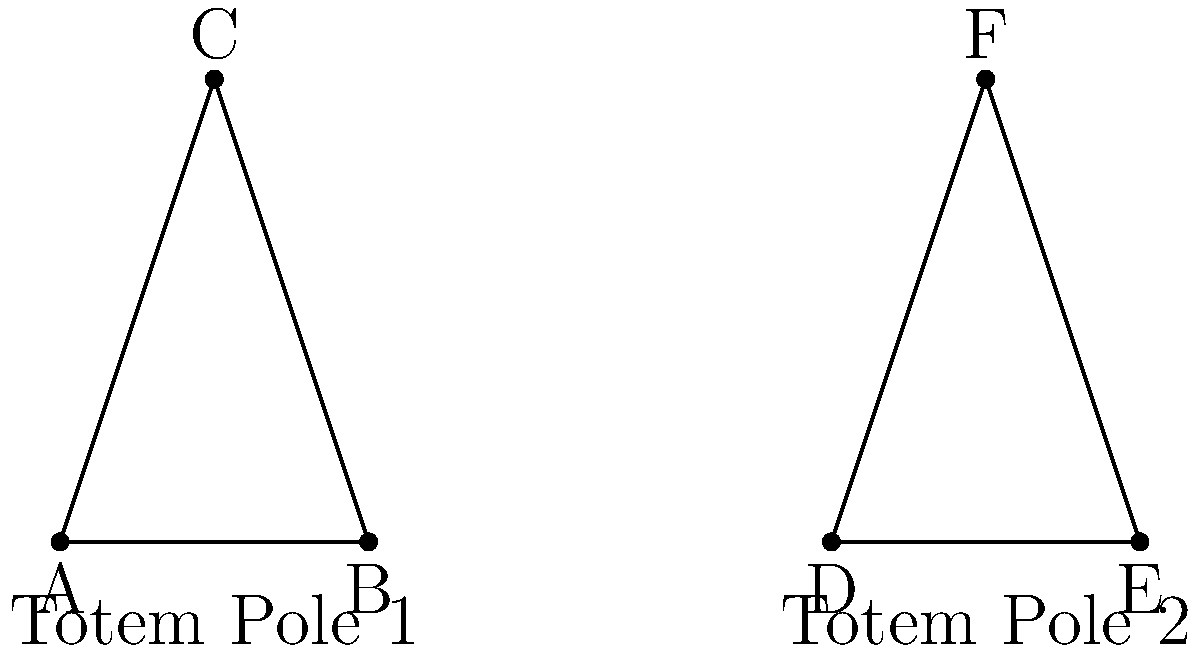Two Native American totem poles were discovered in Snohomish County. The base dimensions and heights of these totem poles are represented by triangles ABC and DEF in the diagram. If AB = 2 units, BC = 3 units, AC = $\sqrt{13}$ units, DE = 2 units, EF = 3 units, and DF = $\sqrt{13}$ units, are these totem poles congruent? To determine if the two totem poles are congruent, we need to check if their representative triangles (ABC and DEF) are congruent. We can use the SSS (Side-Side-Side) congruence criterion for this comparison.

Step 1: Compare the sides of triangle ABC and triangle DEF.
- AB = 2 units and DE = 2 units
- BC = 3 units and EF = 3 units
- AC = $\sqrt{13}$ units and DF = $\sqrt{13}$ units

Step 2: Apply the SSS congruence criterion.
The SSS criterion states that if three sides of one triangle are equal to the corresponding three sides of another triangle, then the triangles are congruent.

In this case:
- AB = DE
- BC = EF
- AC = DF

Step 3: Conclusion
Since all three pairs of corresponding sides are equal, triangles ABC and DEF are congruent according to the SSS criterion.

Therefore, the two Native American totem poles represented by these triangles are congruent.
Answer: Yes, the totem poles are congruent. 